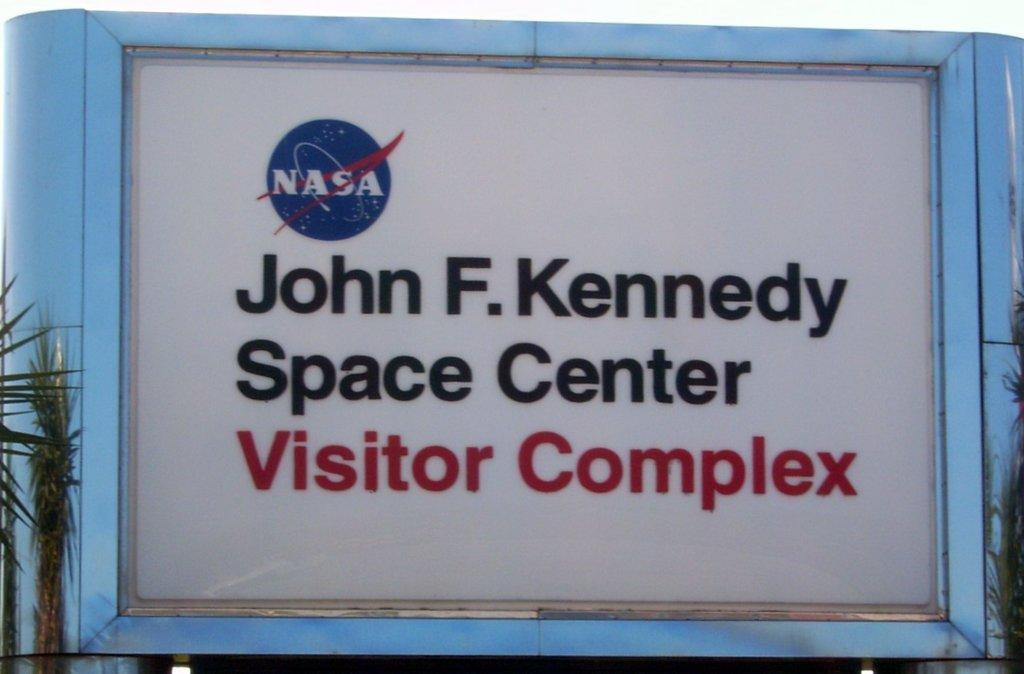<image>
Render a clear and concise summary of the photo. A sign for the visitor complex at the Kennedy Space Center. 